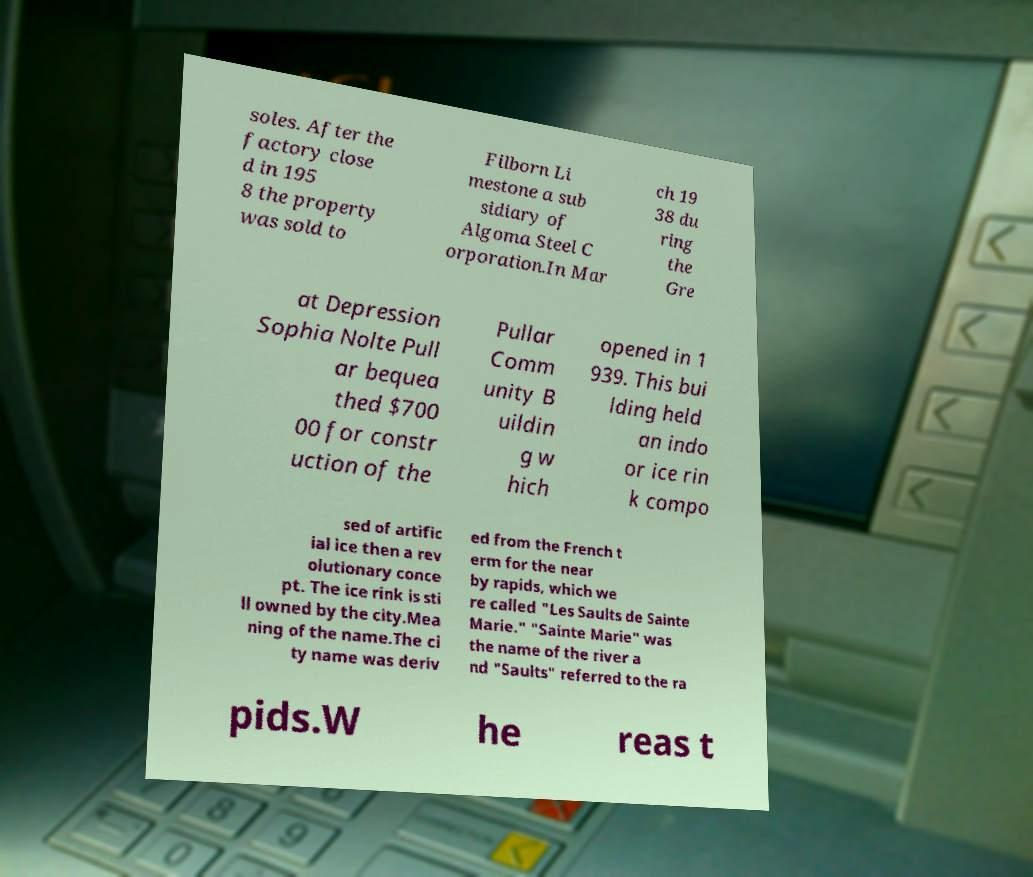Can you read and provide the text displayed in the image?This photo seems to have some interesting text. Can you extract and type it out for me? soles. After the factory close d in 195 8 the property was sold to Filborn Li mestone a sub sidiary of Algoma Steel C orporation.In Mar ch 19 38 du ring the Gre at Depression Sophia Nolte Pull ar bequea thed $700 00 for constr uction of the Pullar Comm unity B uildin g w hich opened in 1 939. This bui lding held an indo or ice rin k compo sed of artific ial ice then a rev olutionary conce pt. The ice rink is sti ll owned by the city.Mea ning of the name.The ci ty name was deriv ed from the French t erm for the near by rapids, which we re called "Les Saults de Sainte Marie." "Sainte Marie" was the name of the river a nd "Saults" referred to the ra pids.W he reas t 